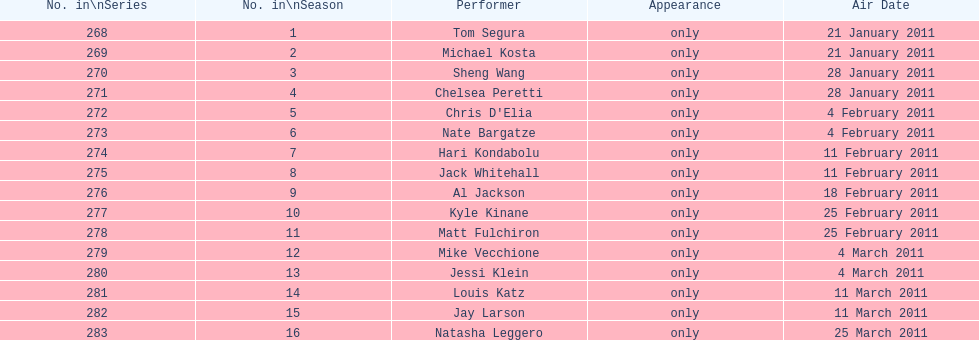How many comedians made their only appearance on comedy central presents in season 15? 16. 